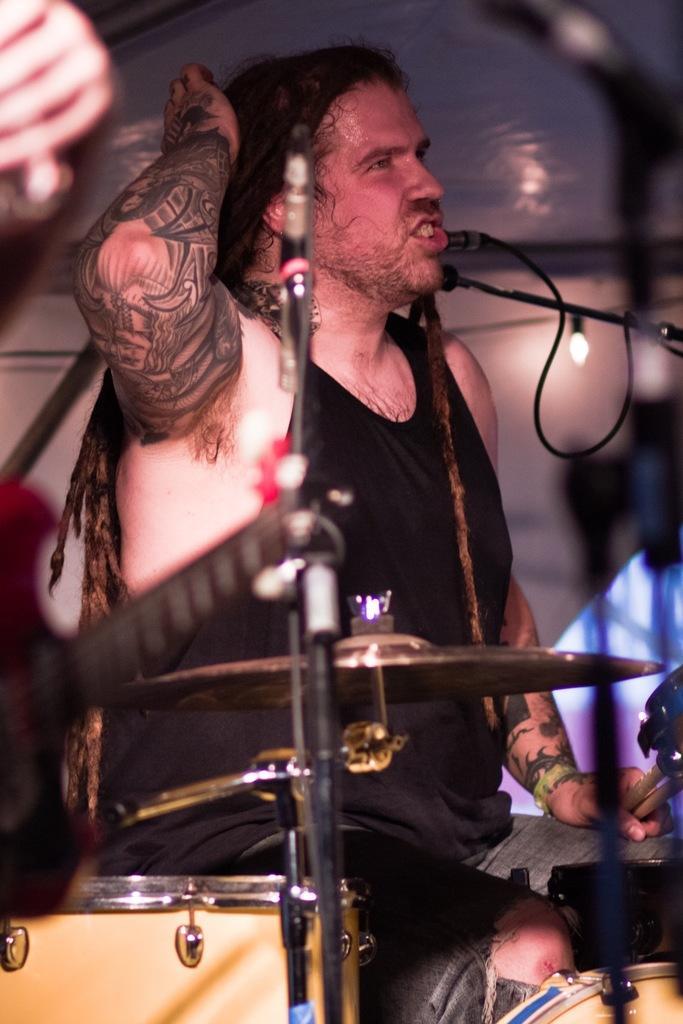Can you describe this image briefly? In this image a man sitting on chair, in front of him there are musical instruments. 